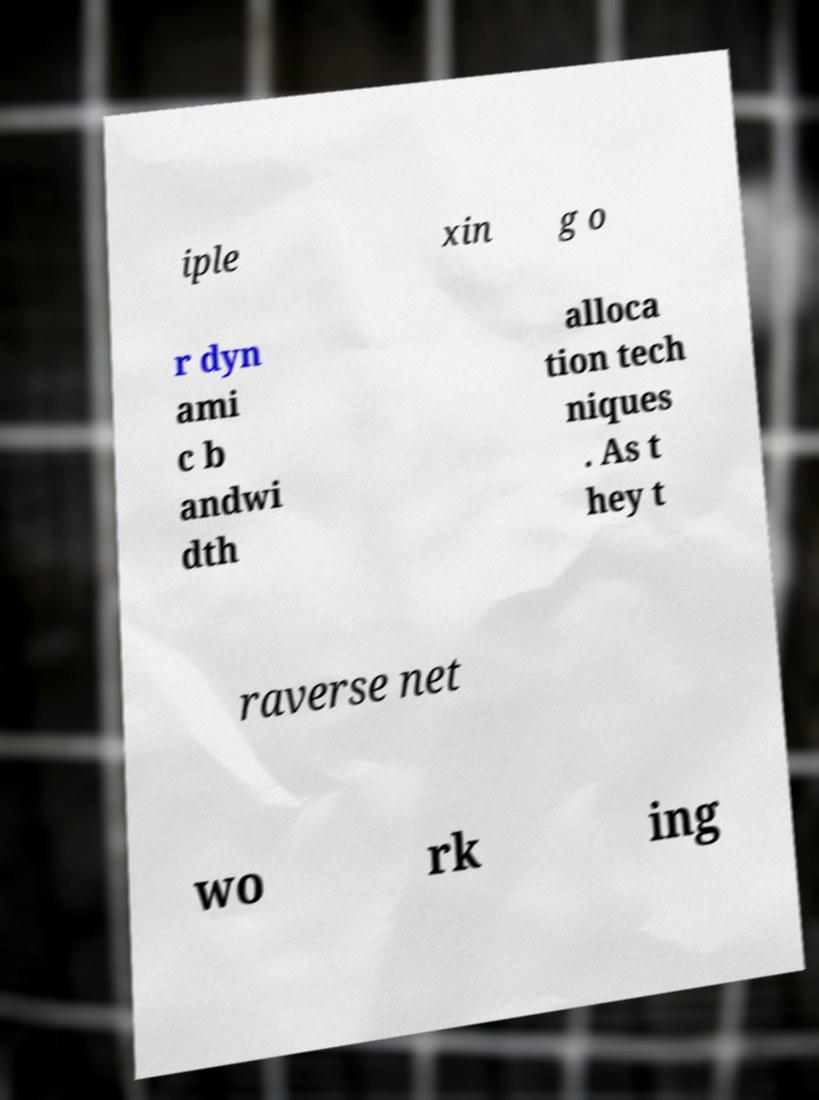There's text embedded in this image that I need extracted. Can you transcribe it verbatim? iple xin g o r dyn ami c b andwi dth alloca tion tech niques . As t hey t raverse net wo rk ing 